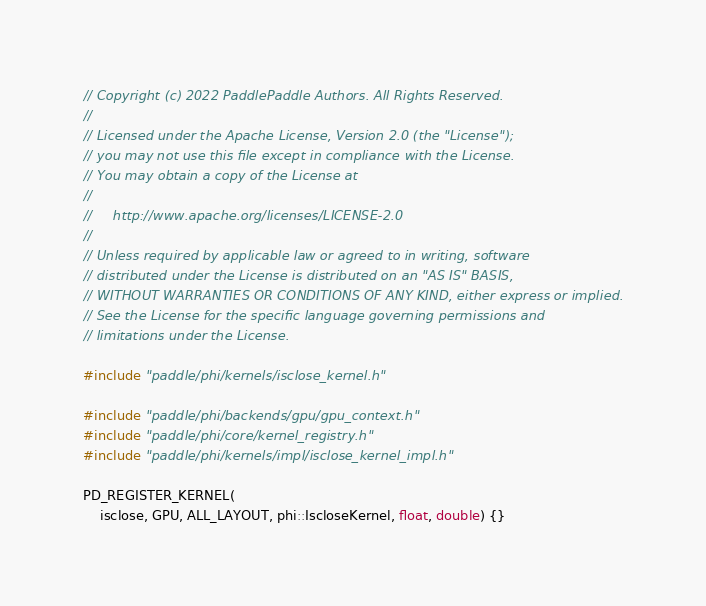Convert code to text. <code><loc_0><loc_0><loc_500><loc_500><_Cuda_>// Copyright (c) 2022 PaddlePaddle Authors. All Rights Reserved.
//
// Licensed under the Apache License, Version 2.0 (the "License");
// you may not use this file except in compliance with the License.
// You may obtain a copy of the License at
//
//     http://www.apache.org/licenses/LICENSE-2.0
//
// Unless required by applicable law or agreed to in writing, software
// distributed under the License is distributed on an "AS IS" BASIS,
// WITHOUT WARRANTIES OR CONDITIONS OF ANY KIND, either express or implied.
// See the License for the specific language governing permissions and
// limitations under the License.

#include "paddle/phi/kernels/isclose_kernel.h"

#include "paddle/phi/backends/gpu/gpu_context.h"
#include "paddle/phi/core/kernel_registry.h"
#include "paddle/phi/kernels/impl/isclose_kernel_impl.h"

PD_REGISTER_KERNEL(
    isclose, GPU, ALL_LAYOUT, phi::IscloseKernel, float, double) {}
</code> 